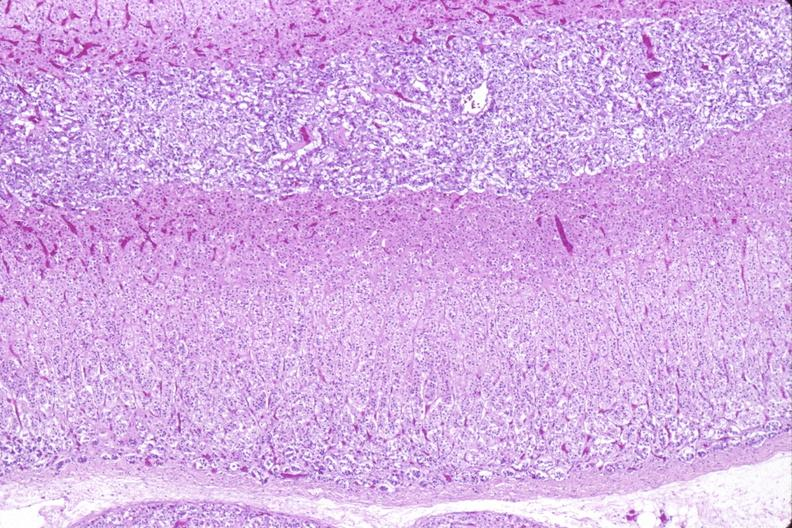what is present?
Answer the question using a single word or phrase. Endocrine 